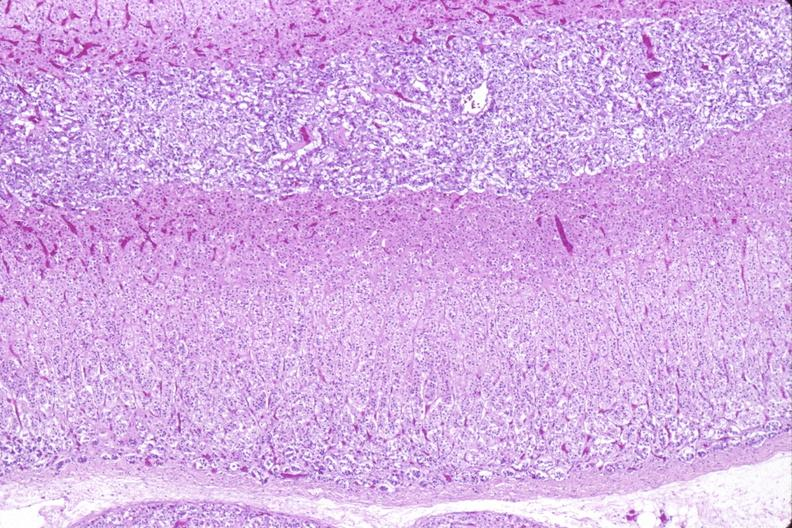what is present?
Answer the question using a single word or phrase. Endocrine 